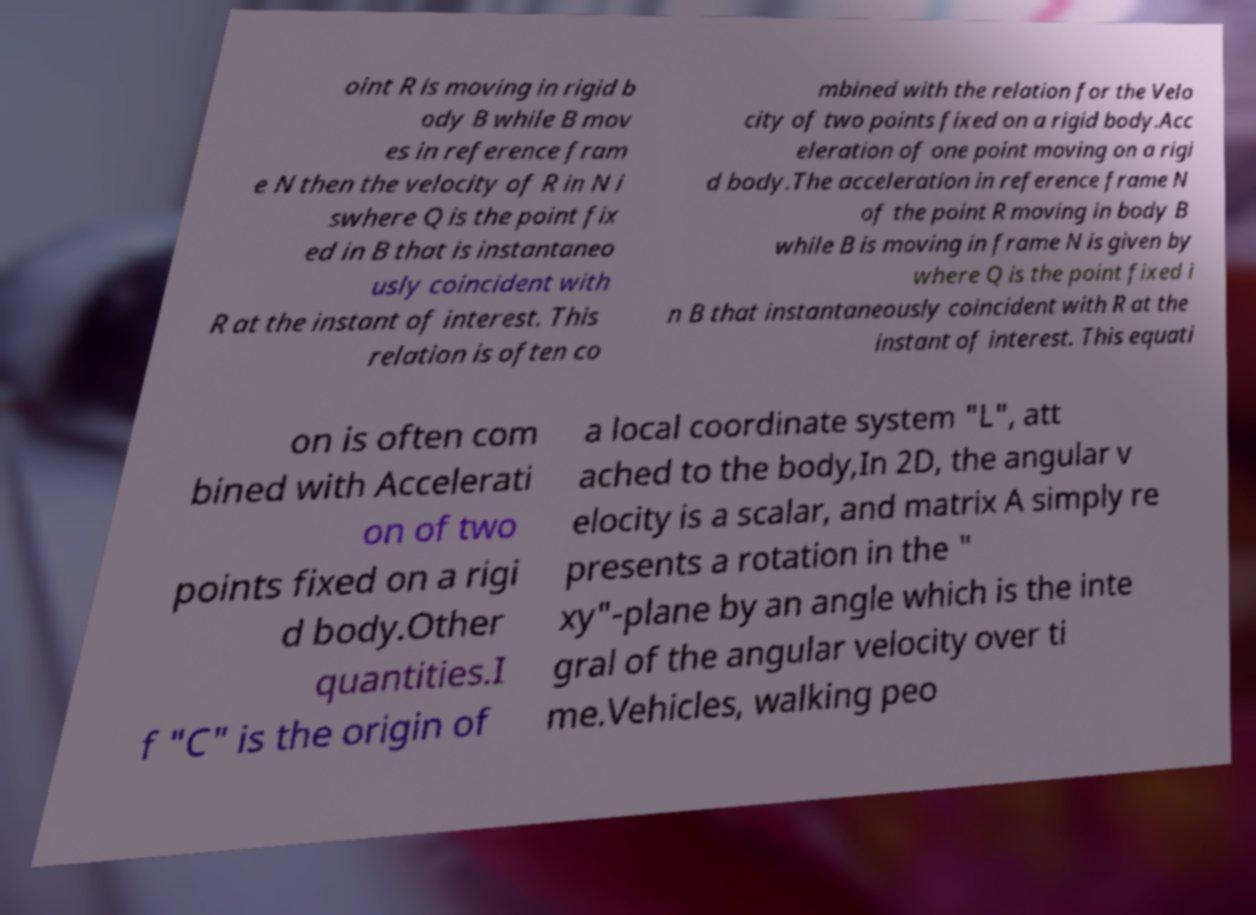Could you extract and type out the text from this image? oint R is moving in rigid b ody B while B mov es in reference fram e N then the velocity of R in N i swhere Q is the point fix ed in B that is instantaneo usly coincident with R at the instant of interest. This relation is often co mbined with the relation for the Velo city of two points fixed on a rigid body.Acc eleration of one point moving on a rigi d body.The acceleration in reference frame N of the point R moving in body B while B is moving in frame N is given by where Q is the point fixed i n B that instantaneously coincident with R at the instant of interest. This equati on is often com bined with Accelerati on of two points fixed on a rigi d body.Other quantities.I f "C" is the origin of a local coordinate system "L", att ached to the body,In 2D, the angular v elocity is a scalar, and matrix A simply re presents a rotation in the " xy"-plane by an angle which is the inte gral of the angular velocity over ti me.Vehicles, walking peo 